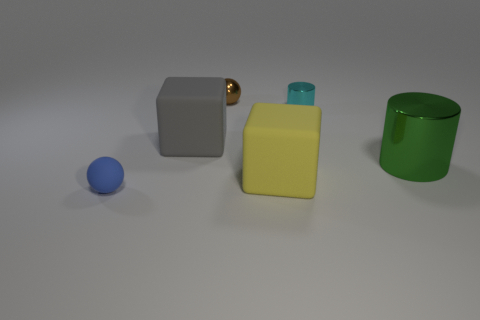How many other large green metallic things have the same shape as the green metallic object?
Your answer should be compact. 0. There is a rubber cube that is in front of the metallic cylinder in front of the tiny cyan metal object; what is its size?
Give a very brief answer. Large. Is the yellow rubber cube the same size as the metal sphere?
Make the answer very short. No. There is a cube on the right side of the block behind the green cylinder; are there any yellow rubber things that are to the right of it?
Keep it short and to the point. No. The brown metal sphere has what size?
Make the answer very short. Small. How many metal cylinders are the same size as the gray rubber object?
Provide a short and direct response. 1. There is a small thing that is the same shape as the big metallic object; what is its material?
Offer a very short reply. Metal. The large thing that is to the left of the large green thing and to the right of the large gray matte object has what shape?
Ensure brevity in your answer.  Cube. There is a small thing that is right of the yellow matte thing; what shape is it?
Offer a very short reply. Cylinder. How many large objects are to the left of the small metal cylinder and in front of the big gray matte thing?
Your response must be concise. 1. 